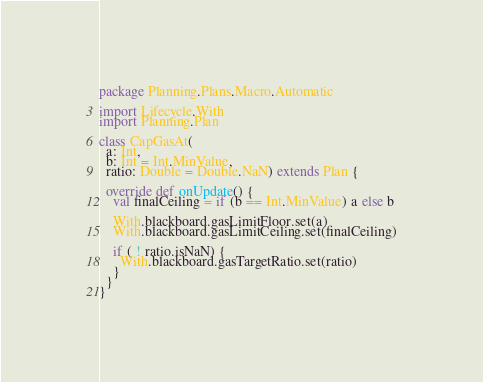<code> <loc_0><loc_0><loc_500><loc_500><_Scala_>package Planning.Plans.Macro.Automatic

import Lifecycle.With
import Planning.Plan

class CapGasAt(
  a: Int,
  b: Int = Int.MinValue,
  ratio: Double = Double.NaN) extends Plan {

  override def onUpdate() {
    val finalCeiling = if (b == Int.MinValue) a else b

    With.blackboard.gasLimitFloor.set(a)
    With.blackboard.gasLimitCeiling.set(finalCeiling)
    
    if ( ! ratio.isNaN) {
      With.blackboard.gasTargetRatio.set(ratio)
    }
  }
}
</code> 